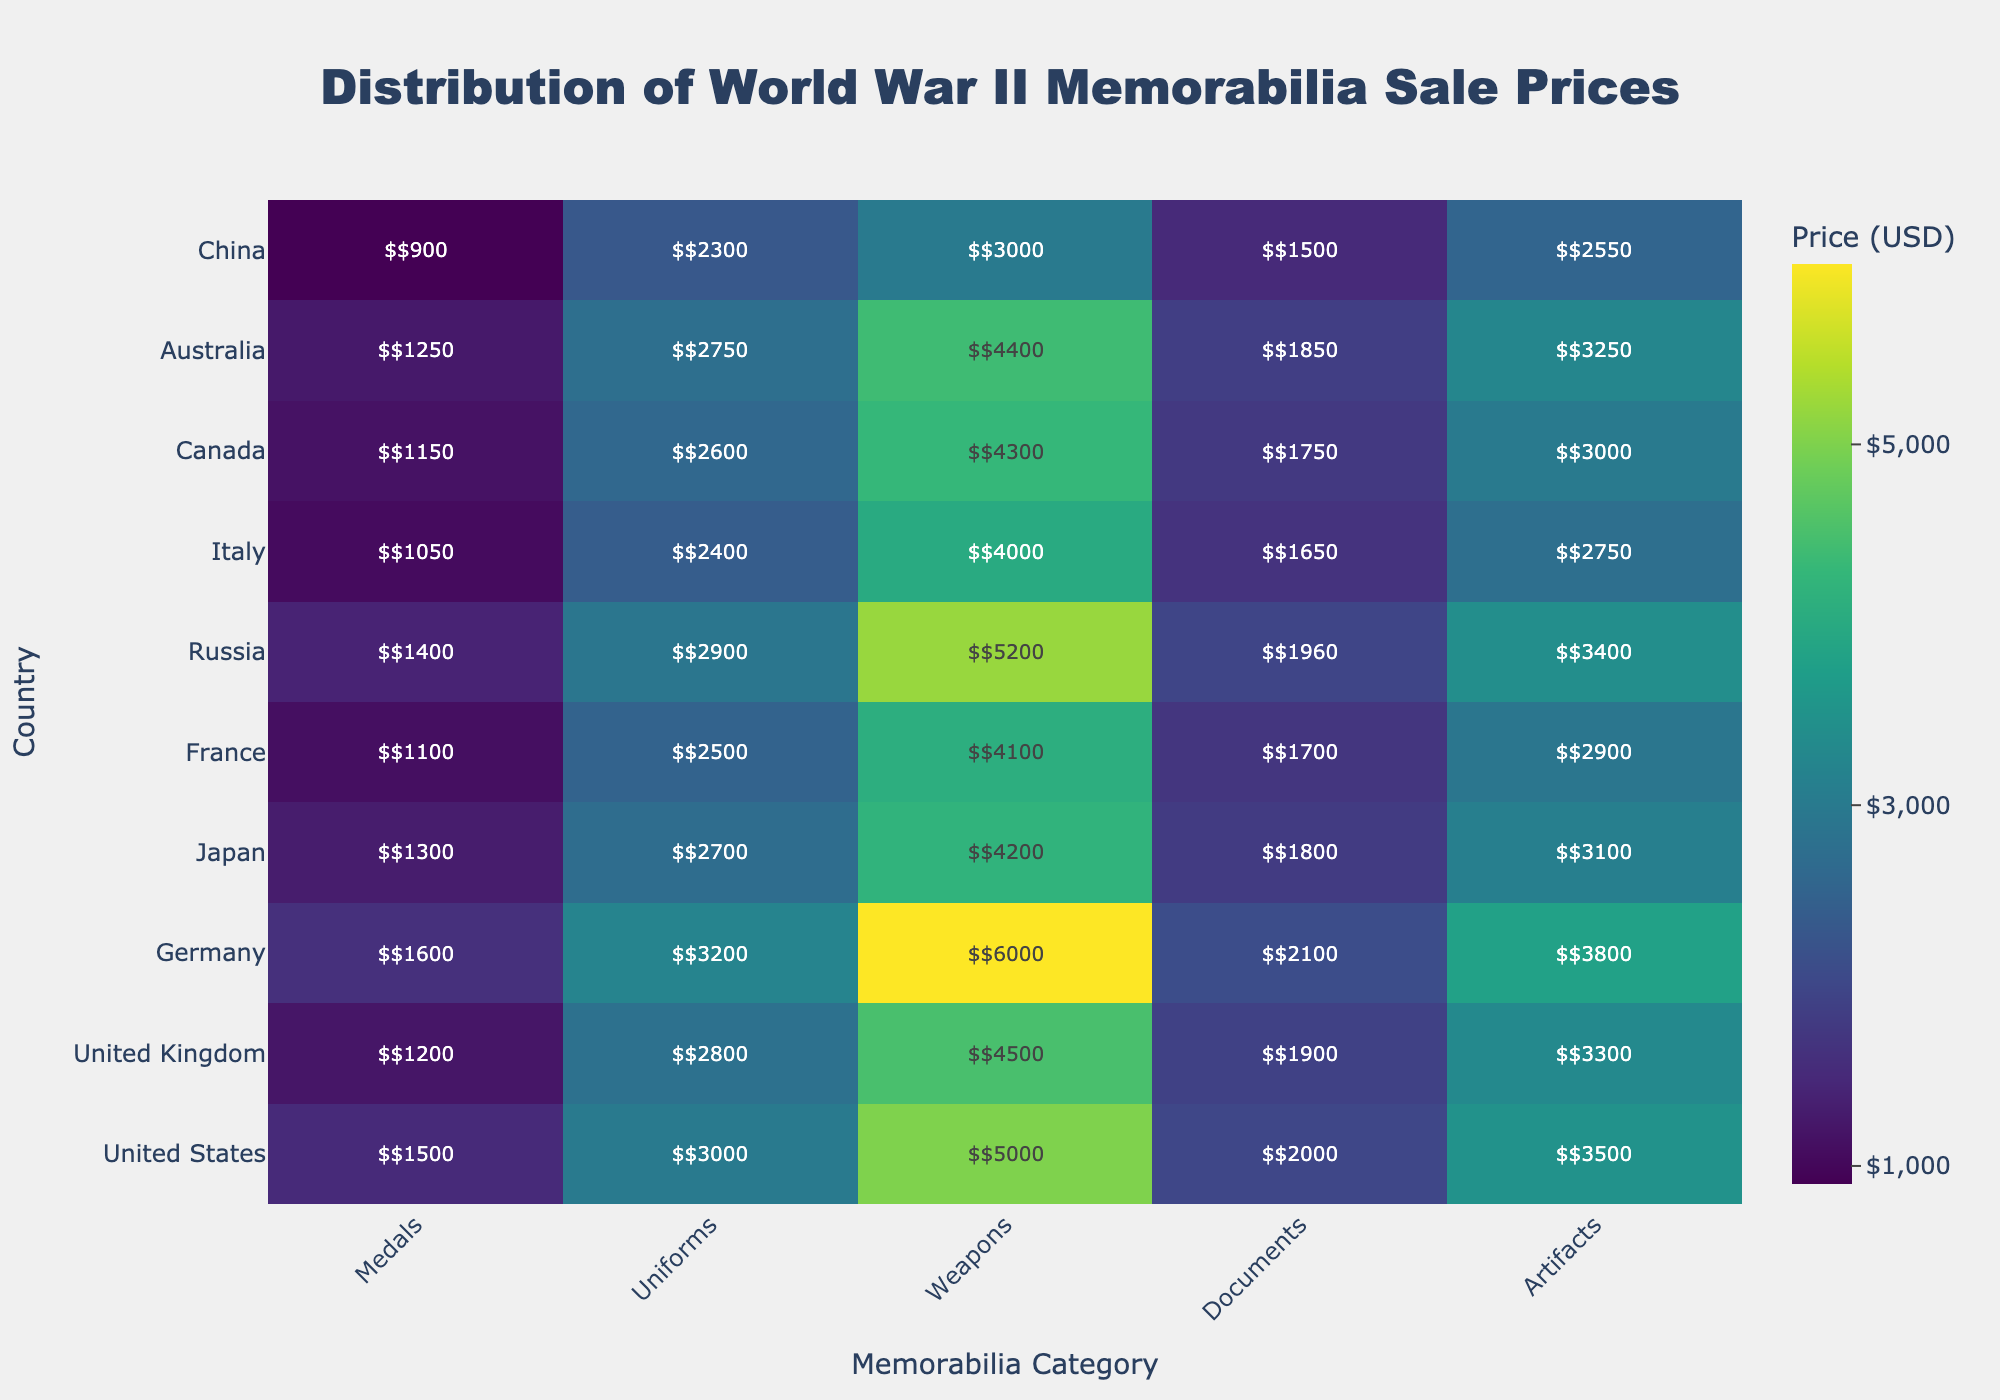How much are the sale prices for uniforms in the United Kingdom? Look at the row for the United Kingdom and then find the value under the 'Uniforms' column.
Answer: $2800 Which country has the highest sale price for weapons? Compare the sale price for weapons across all countries by observing the 'Weapons' column. The highest value is $6000, which corresponds to Germany.
Answer: Germany What is the average sale price of memorabilia items in China? Sum all the values for China (i.e., $900, $2300, $3000, $1500, and $2550) and divide by the number of categories (5). (900 + 2300 + 3000 + 1500 + 2550) / 5 = $2050
Answer: $2050 How does the price of medals in Italy compare to that in Japan? Find the sale price for medals in both Italy ($1050) and Japan ($1300). Italy's price is $250 less than Japan's.
Answer: $250 less Which category has the most consistent (smallest range) prices across all countries? Calculate the range (max price - min price) for each category: Medals, Uniforms, Weapons, Documents, and Artifacts. The category with the smallest range is 'Documents' with a range of $2100 - $1500 = $600.
Answer: Documents What is the difference between the highest and lowest sale prices for artifacts? Identify the highest and lowest values in the 'Artifacts' column: $3800 (Germany) and $2550 (China), then subtract the lowest from the highest. $3800 - $2550 = $1250
Answer: $1250 What is the total sale price of uniforms and weapons in Australia? Add the values for 'Uniforms' and 'Weapons' in Australia: $2750 (Uniforms) + $4400 (Weapons) = $7150
Answer: $7150 Which country has the second highest sale price for documents? Rank the sale prices for documents: Germany ($2100), Russia ($1960), and so on. The second highest price is Russia with $1960.
Answer: Russia Do any countries have the same sale price for any category of memorabilia? Compare each category across all countries. No countries have the exact same sale price for any category of memorabilia.
Answer: No Among the listed countries, which has the lowest overall total sale price for all types of memorabilia? Sum the sale prices for all categories for each country and compare. China has the lowest total: $900 + $2300 + $3000 + $1500 + $2550 = $10250
Answer: China 